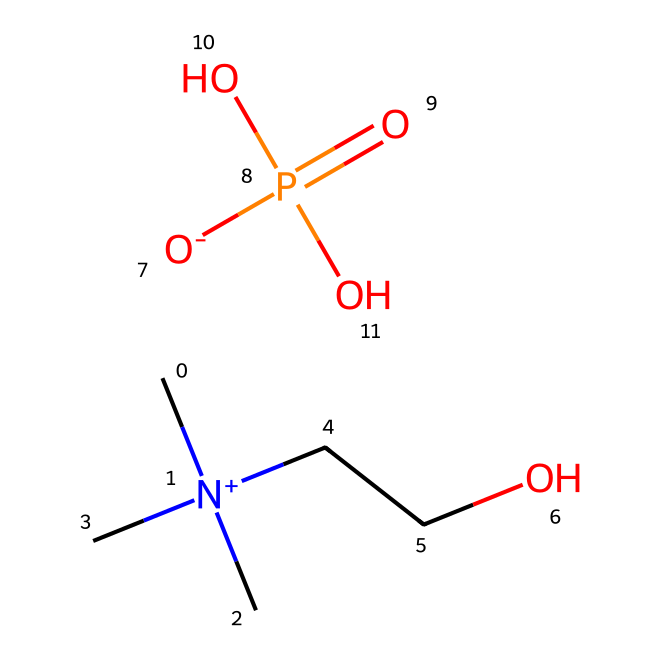What is the molecular formula of choline dihydrogen phosphate? The SMILES representation provides the individual elements present: carbon (C), nitrogen (N), oxygen (O), and phosphorus (P). Counting these gives the formula C5H15N1O4P1.
Answer: C5H15NO4P How many carbon atoms are in the structure? From the SMILES, we can identify the 'C' symbols. There are five occurrences of 'C', indicating there are five carbon atoms in the structure.
Answer: 5 What functional groups are present in this ionic liquid? Analyzing the SMILES, we can find the quaternary ammonium group with 'N+' and the phosphate group, which contains ‘O’ and ‘P’. These indicate it contains an amine and a phosphate functional group.
Answer: Amine and phosphate What is the total number of hydrogen atoms in the structure? In the SMILES, ‘H’ atoms are largely implied through connectivity. Each carbon typically forms four bonds. Analyzing the structure shows there are 15 hydrogen atoms attached, as explicitly counted from the representation.
Answer: 15 How many oxygen atoms are present in the chemical? By examining the SMILES, there are four ‘O’ symbols noted, indicating that the molecule contains four oxygen atoms associated with the phosphate group and the alcohol moiety.
Answer: 4 What distinguishes choline dihydrogen phosphate as an ionic liquid? Ionic liquids are typically characterized by their ability to exist as a liquid at room temperature, and this compound possesses a significant ionic character with both cationic (the choline) and anionic (phosphate) components that contribute to its liquid state.
Answer: Ionic character What potential application does choline dihydrogen phosphate have? Given its properties as an ionic liquid and its biocompatibility, choline dihydrogen phosphate is highlighted for applications in drug delivery systems, owing to the ability to stabilize and enhance the solubility of pharmaceutical compounds.
Answer: Drug delivery 